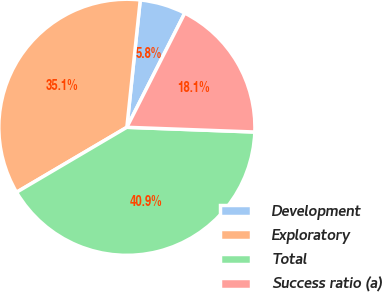Convert chart to OTSL. <chart><loc_0><loc_0><loc_500><loc_500><pie_chart><fcel>Development<fcel>Exploratory<fcel>Total<fcel>Success ratio (a)<nl><fcel>5.8%<fcel>35.14%<fcel>40.94%<fcel>18.12%<nl></chart> 